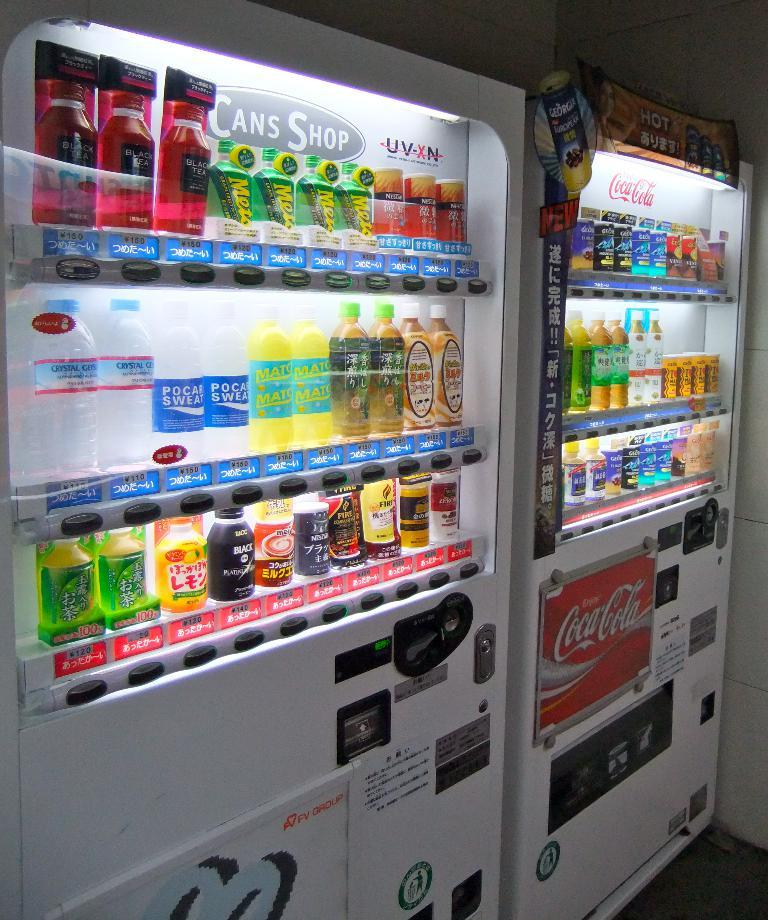<image>
Offer a succinct explanation of the picture presented. Two drinking machines from Coca cola that contains drinks 